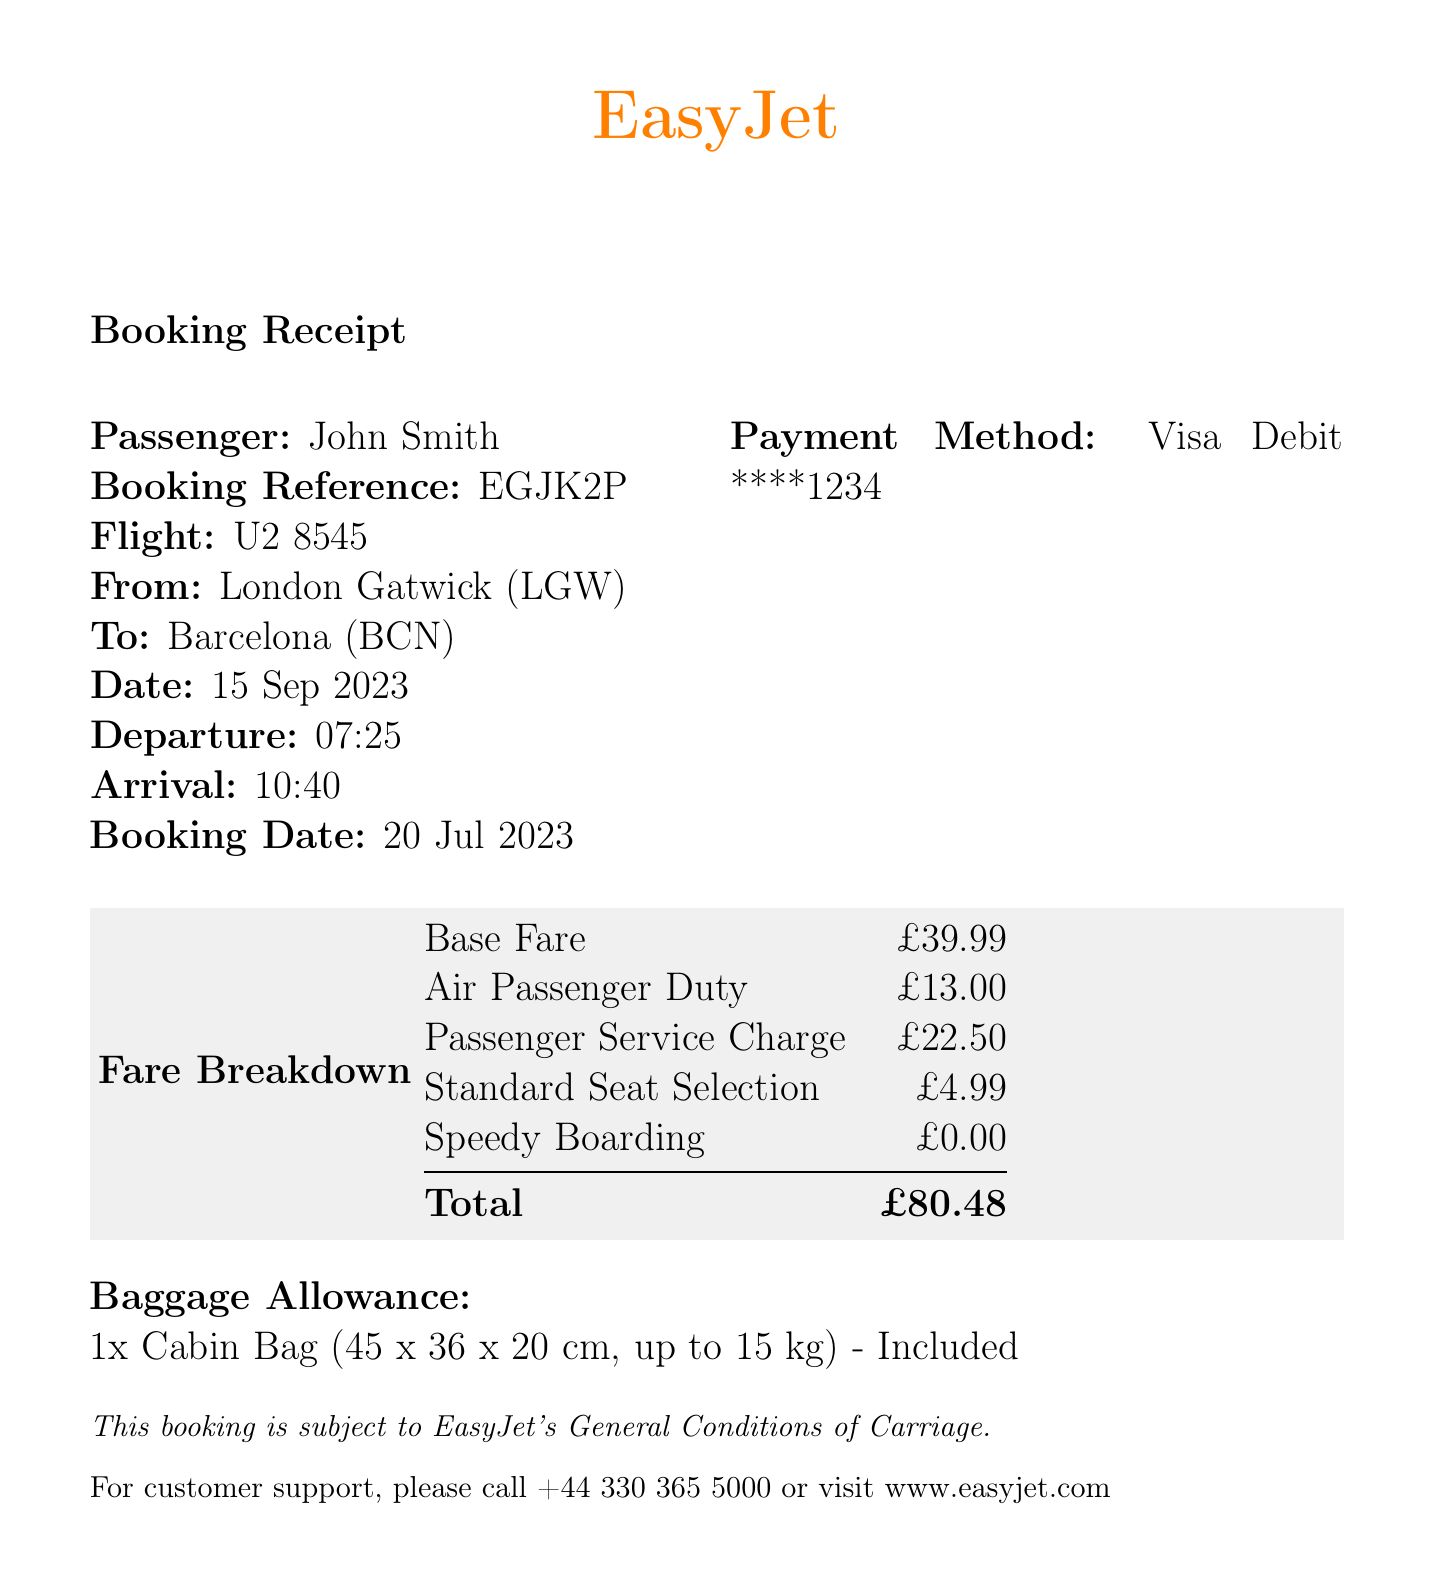What is the airline? The airline is named in the document header.
Answer: EasyJet What is the flight number? The flight number is listed under the booking details.
Answer: U2 8545 What is the total amount paid? The total amount is found in the fare breakdown table.
Answer: £80.48 Who is the passenger? The passenger's name is specified in the document.
Answer: John Smith When is the departure date? The departure date is stated under the flight details.
Answer: 15 Sep 2023 What type of payment method was used? The payment method is included in the booking details section.
Answer: Visa Debit ****1234 How much is the Air Passenger Duty? This fee amount is shown in the fare breakdown section.
Answer: £13.00 How many bags are included in the allowance? The baggage allowance is described in the document.
Answer: 1x Cabin Bag What are the dimensions of the cabin bag? The dimensions for the cabin bag are explicitly mentioned in the baggage section.
Answer: 45 x 36 x 20 cm What is the name of the customer support number? The customer support number is provided at the end of the document.
Answer: +44 330 365 5000 